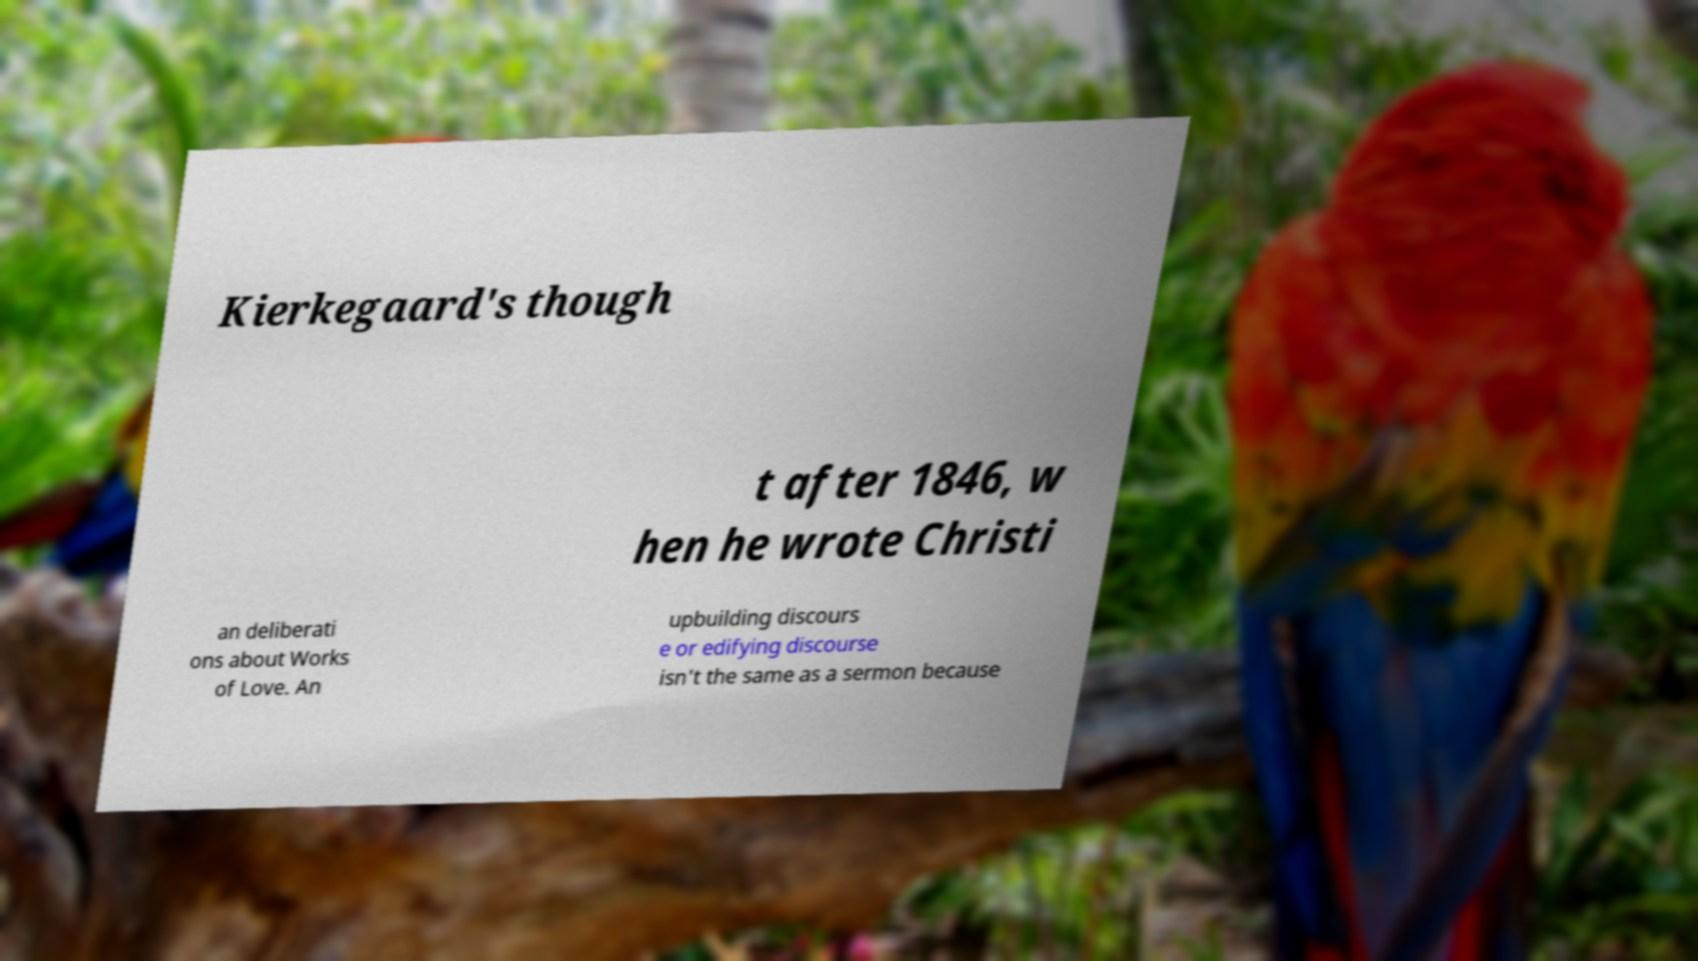Please identify and transcribe the text found in this image. Kierkegaard's though t after 1846, w hen he wrote Christi an deliberati ons about Works of Love. An upbuilding discours e or edifying discourse isn't the same as a sermon because 